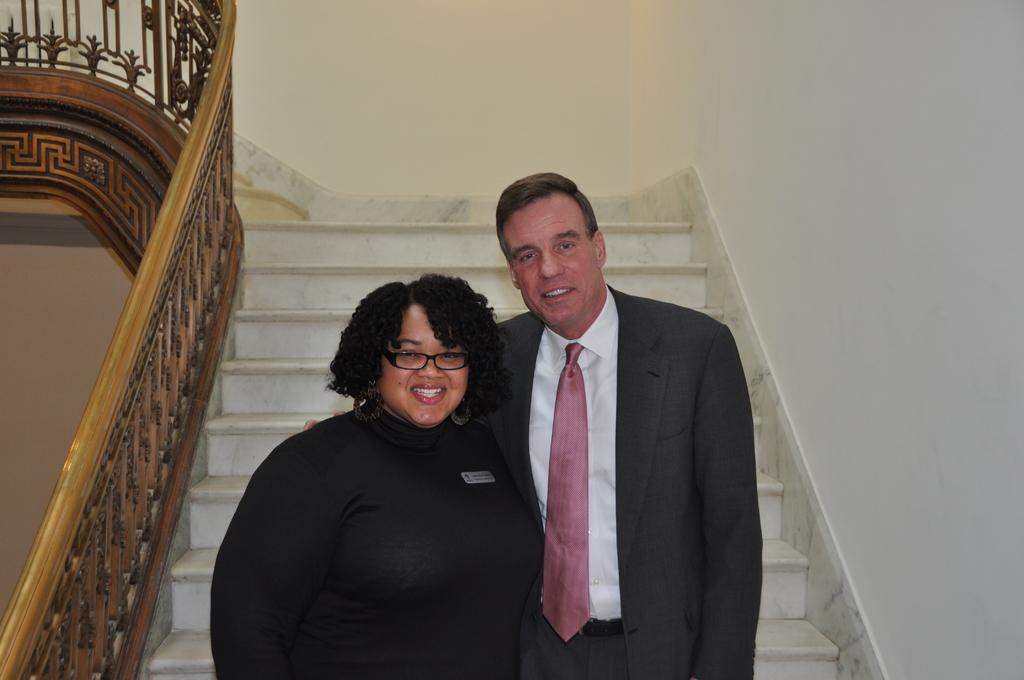What are the two people in the image doing? The man and woman are standing on the stairs in the image. What can be seen near the stairs in the image? There are railings in the image. What size of chalk is being used by the baby in the image? There is no baby present in the image, and therefore no chalk being used. What type of baby is visible in the image? There is no baby present in the image. 